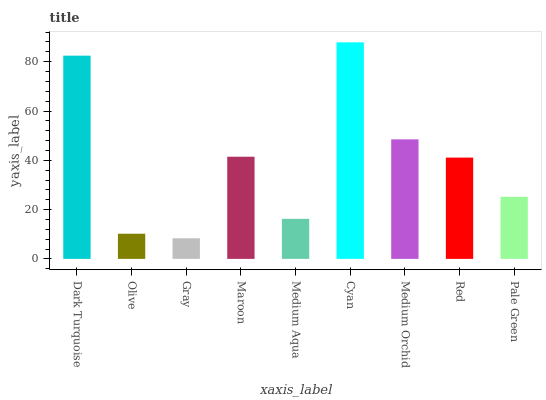Is Olive the minimum?
Answer yes or no. No. Is Olive the maximum?
Answer yes or no. No. Is Dark Turquoise greater than Olive?
Answer yes or no. Yes. Is Olive less than Dark Turquoise?
Answer yes or no. Yes. Is Olive greater than Dark Turquoise?
Answer yes or no. No. Is Dark Turquoise less than Olive?
Answer yes or no. No. Is Red the high median?
Answer yes or no. Yes. Is Red the low median?
Answer yes or no. Yes. Is Dark Turquoise the high median?
Answer yes or no. No. Is Dark Turquoise the low median?
Answer yes or no. No. 